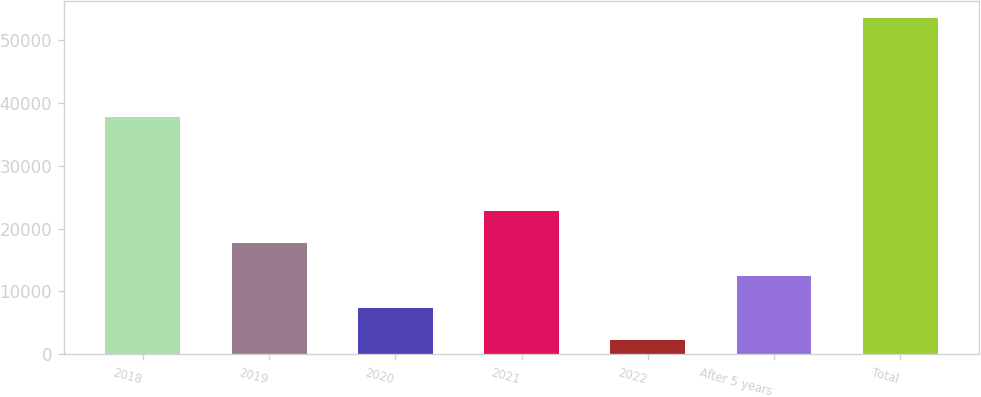<chart> <loc_0><loc_0><loc_500><loc_500><bar_chart><fcel>2018<fcel>2019<fcel>2020<fcel>2021<fcel>2022<fcel>After 5 years<fcel>Total<nl><fcel>37645<fcel>17636<fcel>7410<fcel>22749<fcel>2297<fcel>12523<fcel>53427<nl></chart> 